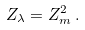Convert formula to latex. <formula><loc_0><loc_0><loc_500><loc_500>Z _ { \lambda } = Z _ { m } ^ { 2 } \, .</formula> 